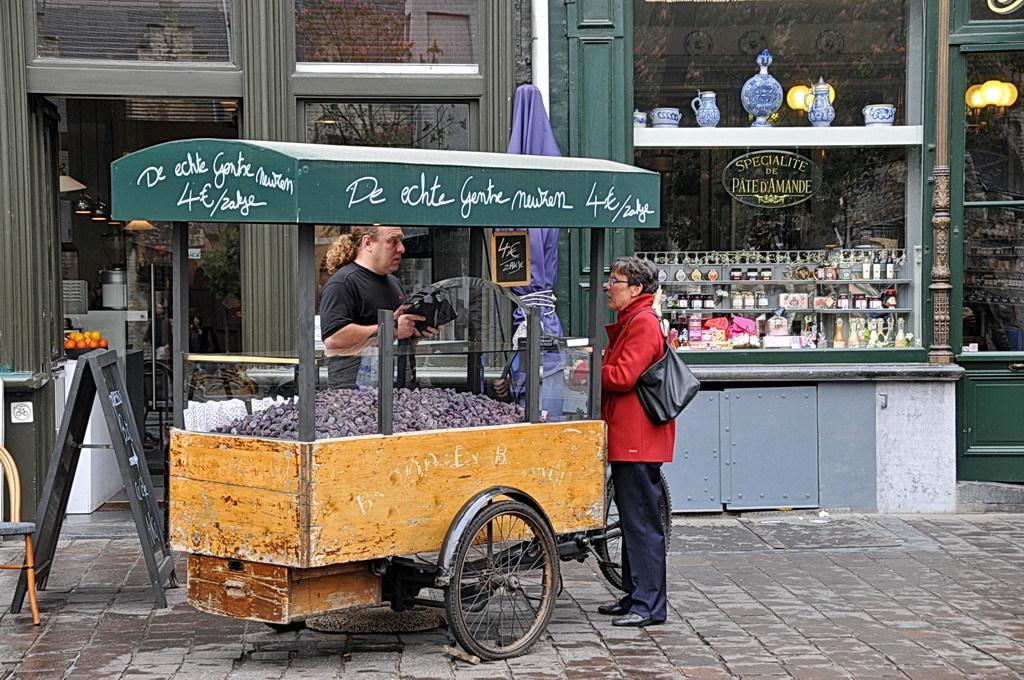How would you summarize this image in a sentence or two? There are two people standing and this person wore bag. We can see cart,board and chair. Background we can see stall and glass,through this glass we can see trees and lights. 